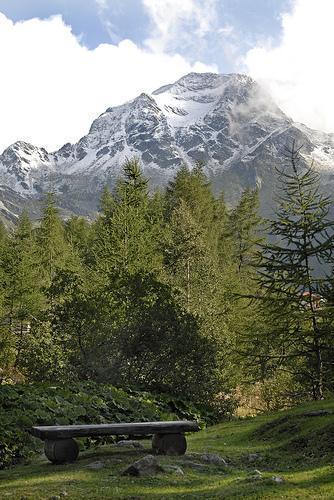How many benches are there?
Give a very brief answer. 1. 